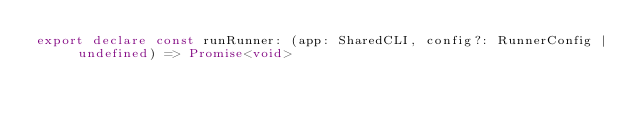Convert code to text. <code><loc_0><loc_0><loc_500><loc_500><_TypeScript_>export declare const runRunner: (app: SharedCLI, config?: RunnerConfig | undefined) => Promise<void>
</code> 